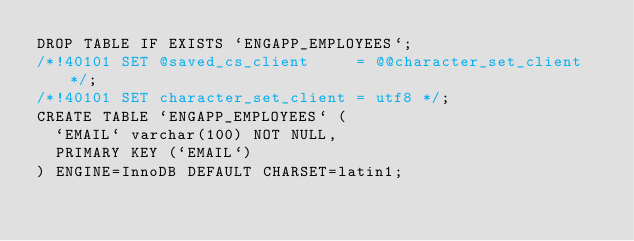<code> <loc_0><loc_0><loc_500><loc_500><_SQL_>DROP TABLE IF EXISTS `ENGAPP_EMPLOYEES`;
/*!40101 SET @saved_cs_client     = @@character_set_client */;
/*!40101 SET character_set_client = utf8 */;
CREATE TABLE `ENGAPP_EMPLOYEES` (
  `EMAIL` varchar(100) NOT NULL,
  PRIMARY KEY (`EMAIL`)
) ENGINE=InnoDB DEFAULT CHARSET=latin1;</code> 